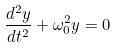Convert formula to latex. <formula><loc_0><loc_0><loc_500><loc_500>\frac { d ^ { 2 } y } { d t ^ { 2 } } + \omega _ { 0 } ^ { 2 } y = 0</formula> 